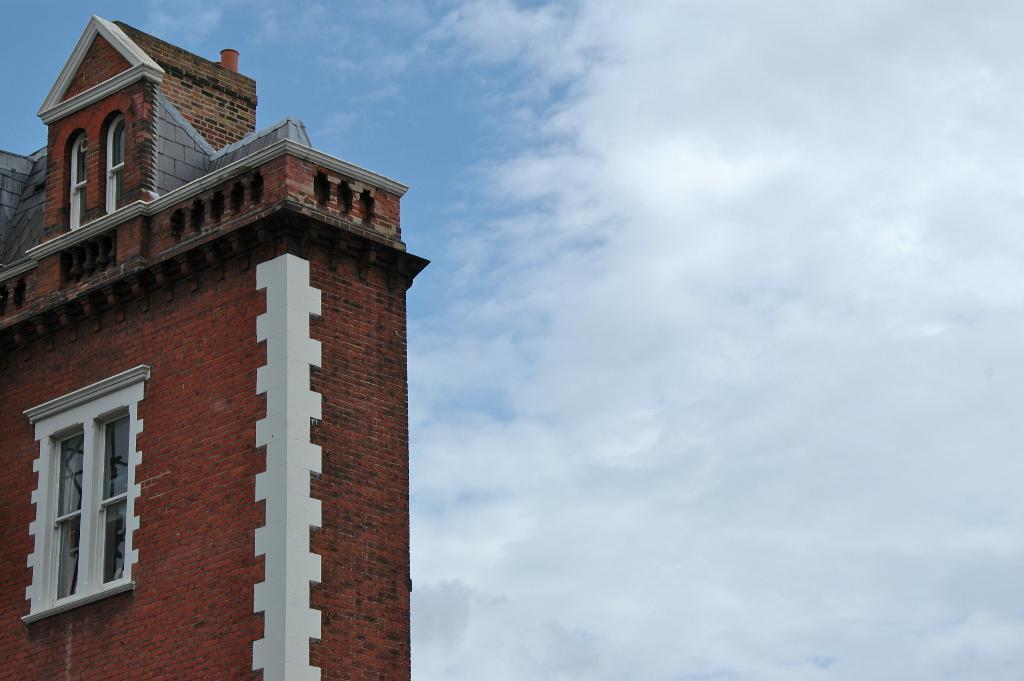Describe this image in one or two sentences. In this picture we can see a building with windows and in the background we can see the sky with clouds. 